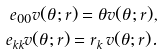<formula> <loc_0><loc_0><loc_500><loc_500>e _ { 0 0 } v ( \theta ; r ) = \theta v ( \theta ; r ) , \\ e _ { k k } v ( \theta ; r ) = r _ { k } \, v ( \theta ; r ) .</formula> 